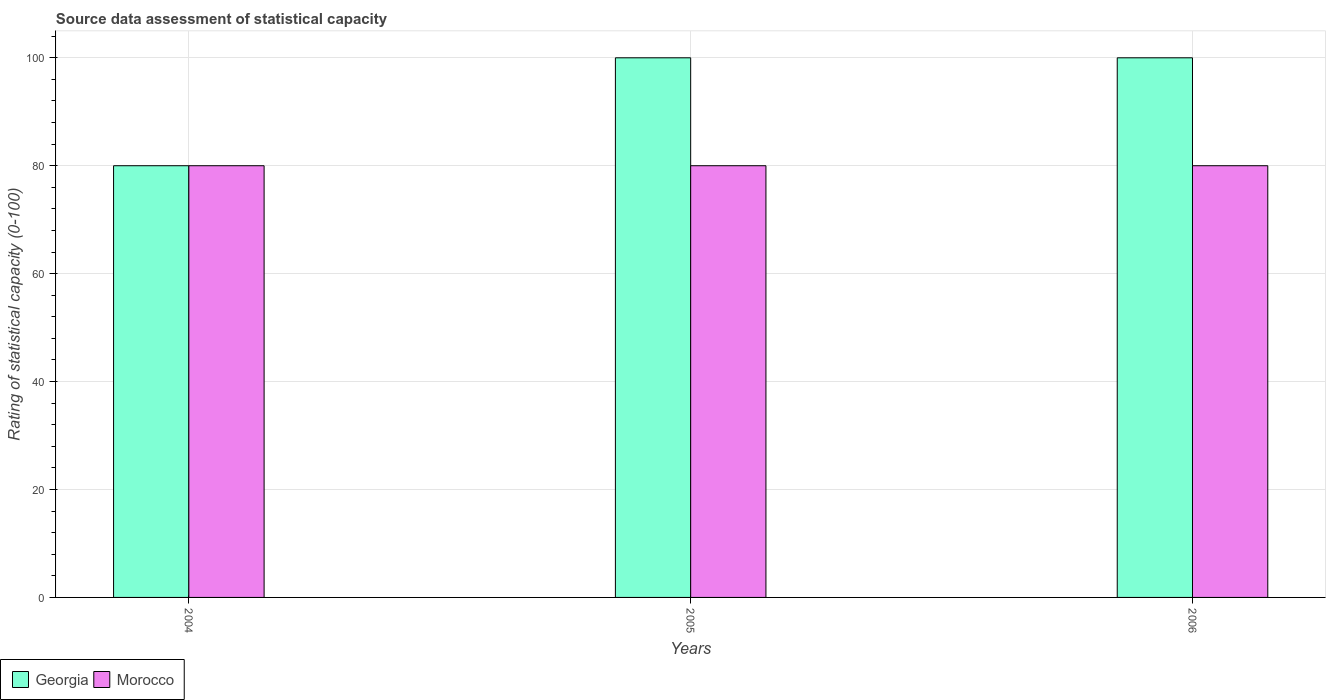How many different coloured bars are there?
Provide a short and direct response. 2. How many groups of bars are there?
Provide a succinct answer. 3. Are the number of bars per tick equal to the number of legend labels?
Ensure brevity in your answer.  Yes. What is the label of the 1st group of bars from the left?
Your response must be concise. 2004. What is the rating of statistical capacity in Morocco in 2006?
Ensure brevity in your answer.  80. Across all years, what is the maximum rating of statistical capacity in Morocco?
Provide a succinct answer. 80. Across all years, what is the minimum rating of statistical capacity in Georgia?
Keep it short and to the point. 80. In which year was the rating of statistical capacity in Georgia maximum?
Provide a succinct answer. 2005. What is the total rating of statistical capacity in Georgia in the graph?
Provide a short and direct response. 280. What is the difference between the rating of statistical capacity in Georgia in 2004 and that in 2006?
Offer a very short reply. -20. What is the difference between the rating of statistical capacity in Morocco in 2005 and the rating of statistical capacity in Georgia in 2004?
Offer a very short reply. 0. What is the average rating of statistical capacity in Georgia per year?
Provide a short and direct response. 93.33. In the year 2005, what is the difference between the rating of statistical capacity in Georgia and rating of statistical capacity in Morocco?
Offer a terse response. 20. What is the ratio of the rating of statistical capacity in Georgia in 2004 to that in 2006?
Offer a terse response. 0.8. Is the difference between the rating of statistical capacity in Georgia in 2005 and 2006 greater than the difference between the rating of statistical capacity in Morocco in 2005 and 2006?
Provide a short and direct response. No. What is the difference between the highest and the second highest rating of statistical capacity in Morocco?
Keep it short and to the point. 0. In how many years, is the rating of statistical capacity in Morocco greater than the average rating of statistical capacity in Morocco taken over all years?
Provide a succinct answer. 0. What does the 2nd bar from the left in 2004 represents?
Your answer should be very brief. Morocco. What does the 1st bar from the right in 2006 represents?
Offer a terse response. Morocco. How many bars are there?
Keep it short and to the point. 6. What is the difference between two consecutive major ticks on the Y-axis?
Make the answer very short. 20. Does the graph contain any zero values?
Keep it short and to the point. No. Where does the legend appear in the graph?
Give a very brief answer. Bottom left. What is the title of the graph?
Your answer should be compact. Source data assessment of statistical capacity. Does "Bosnia and Herzegovina" appear as one of the legend labels in the graph?
Keep it short and to the point. No. What is the label or title of the Y-axis?
Provide a succinct answer. Rating of statistical capacity (0-100). What is the Rating of statistical capacity (0-100) in Georgia in 2004?
Your answer should be very brief. 80. What is the Rating of statistical capacity (0-100) in Morocco in 2004?
Your response must be concise. 80. What is the Rating of statistical capacity (0-100) of Morocco in 2005?
Provide a short and direct response. 80. What is the Rating of statistical capacity (0-100) of Georgia in 2006?
Make the answer very short. 100. What is the Rating of statistical capacity (0-100) in Morocco in 2006?
Provide a short and direct response. 80. Across all years, what is the maximum Rating of statistical capacity (0-100) of Morocco?
Offer a very short reply. 80. What is the total Rating of statistical capacity (0-100) in Georgia in the graph?
Give a very brief answer. 280. What is the total Rating of statistical capacity (0-100) in Morocco in the graph?
Give a very brief answer. 240. What is the difference between the Rating of statistical capacity (0-100) of Georgia in 2004 and that in 2005?
Keep it short and to the point. -20. What is the difference between the Rating of statistical capacity (0-100) in Morocco in 2004 and that in 2005?
Offer a terse response. 0. What is the difference between the Rating of statistical capacity (0-100) in Georgia in 2004 and that in 2006?
Make the answer very short. -20. What is the difference between the Rating of statistical capacity (0-100) in Morocco in 2005 and that in 2006?
Offer a very short reply. 0. What is the difference between the Rating of statistical capacity (0-100) in Georgia in 2004 and the Rating of statistical capacity (0-100) in Morocco in 2006?
Your answer should be very brief. 0. What is the difference between the Rating of statistical capacity (0-100) in Georgia in 2005 and the Rating of statistical capacity (0-100) in Morocco in 2006?
Your response must be concise. 20. What is the average Rating of statistical capacity (0-100) in Georgia per year?
Offer a terse response. 93.33. What is the average Rating of statistical capacity (0-100) in Morocco per year?
Provide a succinct answer. 80. In the year 2004, what is the difference between the Rating of statistical capacity (0-100) in Georgia and Rating of statistical capacity (0-100) in Morocco?
Give a very brief answer. 0. What is the ratio of the Rating of statistical capacity (0-100) of Georgia in 2004 to that in 2005?
Your response must be concise. 0.8. What is the ratio of the Rating of statistical capacity (0-100) in Morocco in 2005 to that in 2006?
Provide a short and direct response. 1. What is the difference between the highest and the second highest Rating of statistical capacity (0-100) in Georgia?
Provide a short and direct response. 0. What is the difference between the highest and the lowest Rating of statistical capacity (0-100) of Morocco?
Your answer should be very brief. 0. 